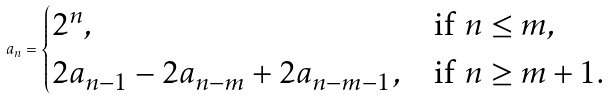<formula> <loc_0><loc_0><loc_500><loc_500>a _ { n } = \begin{cases} 2 ^ { n } , & \text {if } n \leq m , \\ 2 a _ { n - 1 } - 2 a _ { n - m } + 2 a _ { n - m - 1 } , & \text {if } n \geq m + 1 . \end{cases}</formula> 